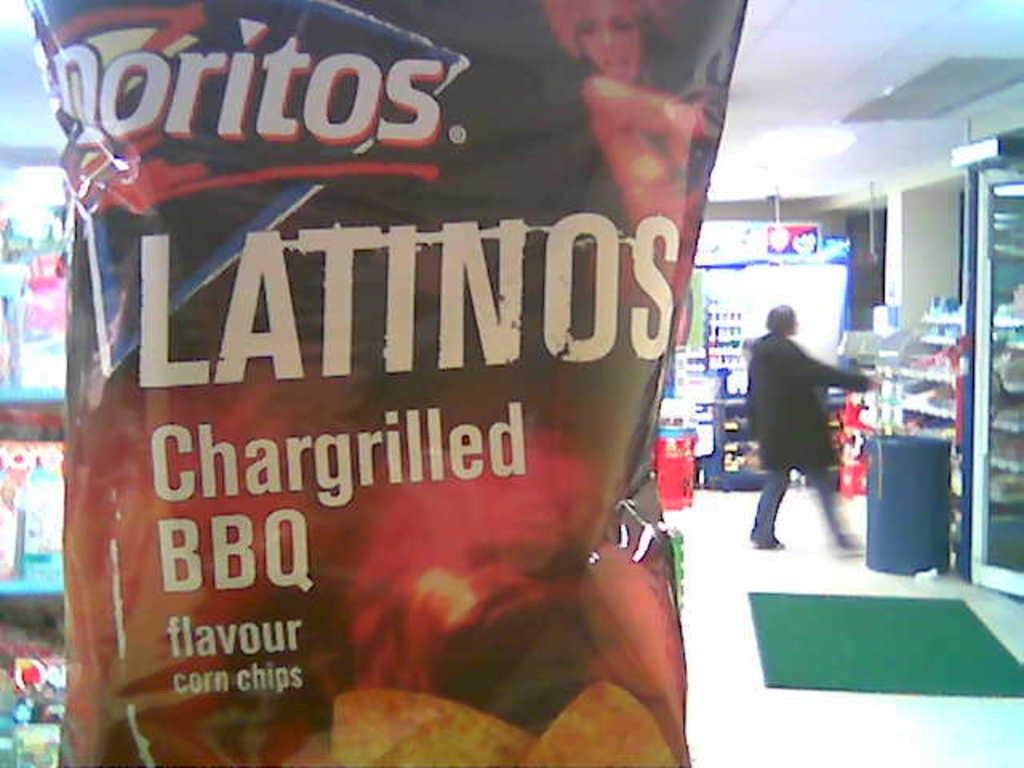What type of location is depicted in the image? The image shows an inside view of a store. What is the man in the image doing? There is a man walking in the store. Can you describe an object near the person in the image? There is an object that looks like a trash bin near the person. What is on the floor in the image? There is a door mat on the floor. What can be seen in the image that is likely to be for sale or purchase? There is a packet visible in the image. How many trees can be seen through the window in the image? There is no window visible in the image, and therefore no trees can be seen through it. 